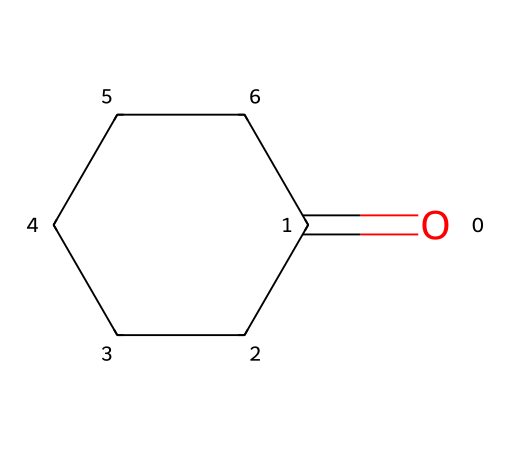What is the molecular formula of cyclohexanone? The structure signifies a cyclohexane ring with a ketone functional group (C=O). Counting the carbon (C) and oxygen (O) atoms gives C6H10O.
Answer: C6H10O How many carbon atoms are present in cyclohexanone? There are six vertices in the ring structure plus one carbon in the carbonyl group, totaling six carbon atoms.
Answer: 6 What type of functional group is present in cyclohexanone? The structure includes a carbonyl group (C=O) which is characteristic of ketones, identifying them as part of this functional group.
Answer: ketone What is the hybridization of the carbon atoms in the ring? The carbon atoms in the cyclohexane part are sp3 hybridized due to their single bonds and tetrahedral geometry in a saturated ring structure.
Answer: sp3 Does cyclohexanone have any chiral centers? Examining the structure, there is no carbon atom bonded to four different substituents, thus no chiral centers are present.
Answer: no What is the degree of saturation of cyclohexanone? Since cyclohexanone has a cyclic structure and contains one double bond from the carbonyl group (C=O), it counts as one degree of unsaturation, making it fully saturated.
Answer: 1 